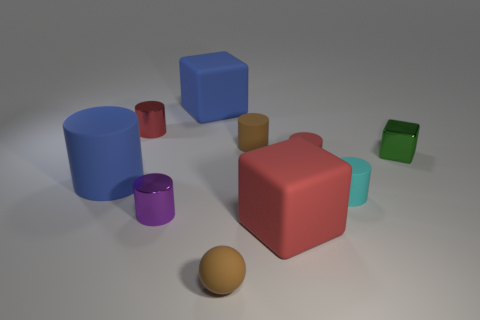How many objects are brown matte objects that are behind the small green shiny thing or big brown matte spheres?
Your answer should be very brief. 1. There is a tiny red thing that is in front of the small brown matte object behind the brown rubber ball; how many purple metallic objects are behind it?
Keep it short and to the point. 0. Is there anything else that is the same size as the red matte cylinder?
Keep it short and to the point. Yes. What shape is the red thing to the left of the small rubber thing in front of the cyan matte cylinder on the right side of the brown cylinder?
Provide a short and direct response. Cylinder. What number of other things are there of the same color as the ball?
Give a very brief answer. 1. What shape is the large blue rubber thing that is on the left side of the tiny metal cylinder that is behind the big blue cylinder?
Offer a very short reply. Cylinder. There is a small purple object; what number of cyan rubber cylinders are in front of it?
Keep it short and to the point. 0. Are there any large blue cylinders made of the same material as the small sphere?
Offer a terse response. Yes. There is a purple object that is the same size as the red rubber cylinder; what is its material?
Give a very brief answer. Metal. There is a shiny thing that is behind the tiny cyan matte thing and to the left of the small green object; how big is it?
Offer a very short reply. Small. 